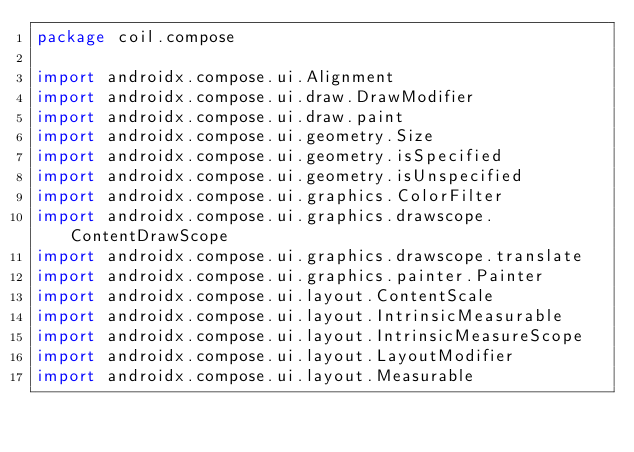<code> <loc_0><loc_0><loc_500><loc_500><_Kotlin_>package coil.compose

import androidx.compose.ui.Alignment
import androidx.compose.ui.draw.DrawModifier
import androidx.compose.ui.draw.paint
import androidx.compose.ui.geometry.Size
import androidx.compose.ui.geometry.isSpecified
import androidx.compose.ui.geometry.isUnspecified
import androidx.compose.ui.graphics.ColorFilter
import androidx.compose.ui.graphics.drawscope.ContentDrawScope
import androidx.compose.ui.graphics.drawscope.translate
import androidx.compose.ui.graphics.painter.Painter
import androidx.compose.ui.layout.ContentScale
import androidx.compose.ui.layout.IntrinsicMeasurable
import androidx.compose.ui.layout.IntrinsicMeasureScope
import androidx.compose.ui.layout.LayoutModifier
import androidx.compose.ui.layout.Measurable</code> 